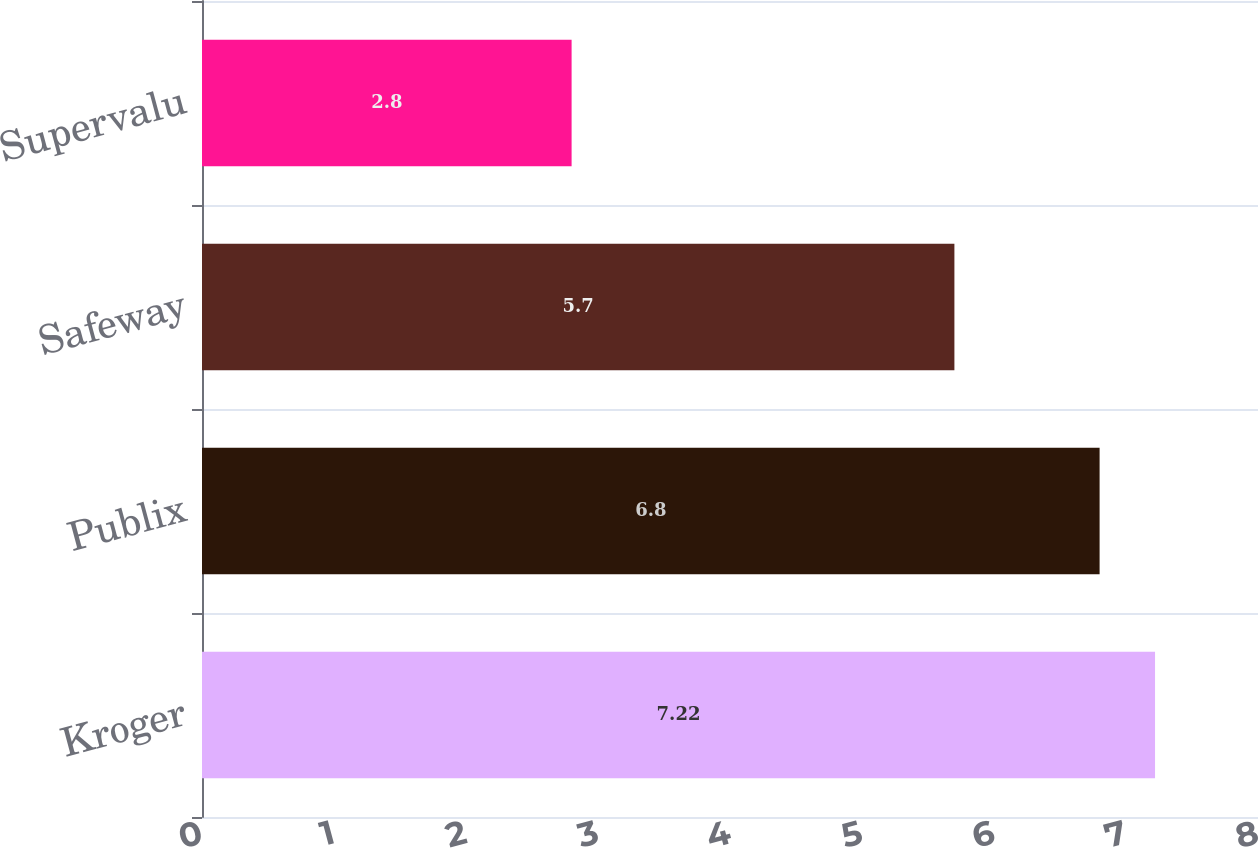Convert chart. <chart><loc_0><loc_0><loc_500><loc_500><bar_chart><fcel>Kroger<fcel>Publix<fcel>Safeway<fcel>Supervalu<nl><fcel>7.22<fcel>6.8<fcel>5.7<fcel>2.8<nl></chart> 